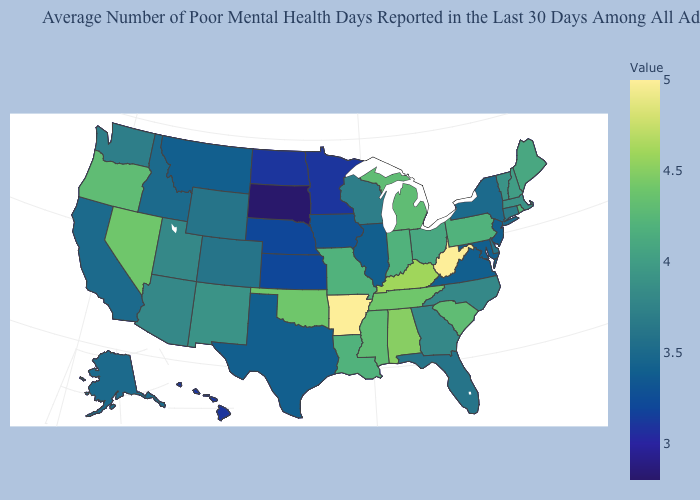Does West Virginia have the highest value in the South?
Answer briefly. Yes. Among the states that border Illinois , which have the highest value?
Quick response, please. Kentucky. Which states have the highest value in the USA?
Concise answer only. Arkansas, West Virginia. Does Georgia have a lower value than South Dakota?
Give a very brief answer. No. Which states have the lowest value in the USA?
Concise answer only. South Dakota. Among the states that border Massachusetts , which have the highest value?
Be succinct. Rhode Island. Does Nevada have the highest value in the West?
Concise answer only. Yes. Does Massachusetts have the highest value in the Northeast?
Be succinct. No. 